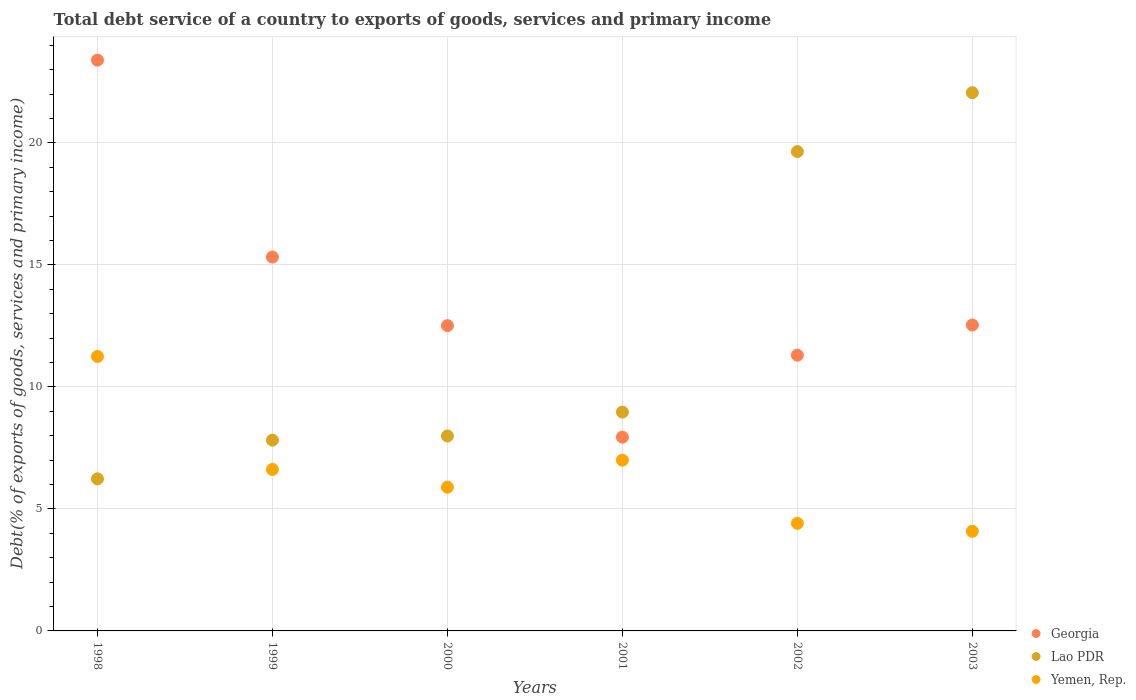How many different coloured dotlines are there?
Provide a succinct answer. 3. Is the number of dotlines equal to the number of legend labels?
Ensure brevity in your answer.  Yes. What is the total debt service in Georgia in 2003?
Ensure brevity in your answer.  12.54. Across all years, what is the maximum total debt service in Yemen, Rep.?
Offer a terse response. 11.25. Across all years, what is the minimum total debt service in Yemen, Rep.?
Your answer should be compact. 4.08. In which year was the total debt service in Lao PDR maximum?
Keep it short and to the point. 2003. In which year was the total debt service in Georgia minimum?
Offer a very short reply. 2001. What is the total total debt service in Georgia in the graph?
Provide a short and direct response. 83.01. What is the difference between the total debt service in Georgia in 1999 and that in 2001?
Offer a very short reply. 7.38. What is the difference between the total debt service in Yemen, Rep. in 2003 and the total debt service in Lao PDR in 2001?
Keep it short and to the point. -4.88. What is the average total debt service in Georgia per year?
Keep it short and to the point. 13.83. In the year 2000, what is the difference between the total debt service in Georgia and total debt service in Lao PDR?
Ensure brevity in your answer.  4.52. In how many years, is the total debt service in Georgia greater than 17 %?
Make the answer very short. 1. What is the ratio of the total debt service in Yemen, Rep. in 2000 to that in 2002?
Offer a terse response. 1.34. What is the difference between the highest and the second highest total debt service in Georgia?
Your answer should be compact. 8.07. What is the difference between the highest and the lowest total debt service in Yemen, Rep.?
Make the answer very short. 7.16. In how many years, is the total debt service in Georgia greater than the average total debt service in Georgia taken over all years?
Provide a succinct answer. 2. Is it the case that in every year, the sum of the total debt service in Georgia and total debt service in Yemen, Rep.  is greater than the total debt service in Lao PDR?
Your answer should be very brief. No. Is the total debt service in Georgia strictly greater than the total debt service in Yemen, Rep. over the years?
Give a very brief answer. Yes. How many years are there in the graph?
Your answer should be compact. 6. What is the difference between two consecutive major ticks on the Y-axis?
Your answer should be compact. 5. Does the graph contain any zero values?
Make the answer very short. No. Does the graph contain grids?
Keep it short and to the point. Yes. How are the legend labels stacked?
Your answer should be very brief. Vertical. What is the title of the graph?
Provide a short and direct response. Total debt service of a country to exports of goods, services and primary income. What is the label or title of the X-axis?
Offer a very short reply. Years. What is the label or title of the Y-axis?
Provide a succinct answer. Debt(% of exports of goods, services and primary income). What is the Debt(% of exports of goods, services and primary income) in Georgia in 1998?
Provide a succinct answer. 23.39. What is the Debt(% of exports of goods, services and primary income) of Lao PDR in 1998?
Offer a terse response. 6.23. What is the Debt(% of exports of goods, services and primary income) in Yemen, Rep. in 1998?
Your response must be concise. 11.25. What is the Debt(% of exports of goods, services and primary income) in Georgia in 1999?
Provide a short and direct response. 15.32. What is the Debt(% of exports of goods, services and primary income) of Lao PDR in 1999?
Make the answer very short. 7.82. What is the Debt(% of exports of goods, services and primary income) in Yemen, Rep. in 1999?
Make the answer very short. 6.62. What is the Debt(% of exports of goods, services and primary income) in Georgia in 2000?
Offer a very short reply. 12.51. What is the Debt(% of exports of goods, services and primary income) in Lao PDR in 2000?
Your response must be concise. 7.99. What is the Debt(% of exports of goods, services and primary income) in Yemen, Rep. in 2000?
Provide a short and direct response. 5.89. What is the Debt(% of exports of goods, services and primary income) of Georgia in 2001?
Provide a succinct answer. 7.94. What is the Debt(% of exports of goods, services and primary income) in Lao PDR in 2001?
Your response must be concise. 8.97. What is the Debt(% of exports of goods, services and primary income) of Yemen, Rep. in 2001?
Provide a succinct answer. 7. What is the Debt(% of exports of goods, services and primary income) in Georgia in 2002?
Your answer should be very brief. 11.3. What is the Debt(% of exports of goods, services and primary income) of Lao PDR in 2002?
Ensure brevity in your answer.  19.65. What is the Debt(% of exports of goods, services and primary income) in Yemen, Rep. in 2002?
Keep it short and to the point. 4.41. What is the Debt(% of exports of goods, services and primary income) of Georgia in 2003?
Your response must be concise. 12.54. What is the Debt(% of exports of goods, services and primary income) in Lao PDR in 2003?
Your answer should be compact. 22.06. What is the Debt(% of exports of goods, services and primary income) in Yemen, Rep. in 2003?
Provide a succinct answer. 4.08. Across all years, what is the maximum Debt(% of exports of goods, services and primary income) of Georgia?
Your response must be concise. 23.39. Across all years, what is the maximum Debt(% of exports of goods, services and primary income) in Lao PDR?
Your response must be concise. 22.06. Across all years, what is the maximum Debt(% of exports of goods, services and primary income) in Yemen, Rep.?
Provide a short and direct response. 11.25. Across all years, what is the minimum Debt(% of exports of goods, services and primary income) of Georgia?
Make the answer very short. 7.94. Across all years, what is the minimum Debt(% of exports of goods, services and primary income) in Lao PDR?
Your answer should be compact. 6.23. Across all years, what is the minimum Debt(% of exports of goods, services and primary income) of Yemen, Rep.?
Your response must be concise. 4.08. What is the total Debt(% of exports of goods, services and primary income) in Georgia in the graph?
Provide a short and direct response. 83.01. What is the total Debt(% of exports of goods, services and primary income) of Lao PDR in the graph?
Your answer should be very brief. 72.71. What is the total Debt(% of exports of goods, services and primary income) of Yemen, Rep. in the graph?
Offer a very short reply. 39.25. What is the difference between the Debt(% of exports of goods, services and primary income) of Georgia in 1998 and that in 1999?
Offer a terse response. 8.07. What is the difference between the Debt(% of exports of goods, services and primary income) in Lao PDR in 1998 and that in 1999?
Offer a very short reply. -1.58. What is the difference between the Debt(% of exports of goods, services and primary income) in Yemen, Rep. in 1998 and that in 1999?
Offer a terse response. 4.63. What is the difference between the Debt(% of exports of goods, services and primary income) of Georgia in 1998 and that in 2000?
Keep it short and to the point. 10.88. What is the difference between the Debt(% of exports of goods, services and primary income) of Lao PDR in 1998 and that in 2000?
Provide a succinct answer. -1.76. What is the difference between the Debt(% of exports of goods, services and primary income) of Yemen, Rep. in 1998 and that in 2000?
Offer a very short reply. 5.36. What is the difference between the Debt(% of exports of goods, services and primary income) of Georgia in 1998 and that in 2001?
Ensure brevity in your answer.  15.45. What is the difference between the Debt(% of exports of goods, services and primary income) in Lao PDR in 1998 and that in 2001?
Offer a very short reply. -2.74. What is the difference between the Debt(% of exports of goods, services and primary income) in Yemen, Rep. in 1998 and that in 2001?
Provide a succinct answer. 4.25. What is the difference between the Debt(% of exports of goods, services and primary income) in Georgia in 1998 and that in 2002?
Make the answer very short. 12.09. What is the difference between the Debt(% of exports of goods, services and primary income) in Lao PDR in 1998 and that in 2002?
Keep it short and to the point. -13.41. What is the difference between the Debt(% of exports of goods, services and primary income) in Yemen, Rep. in 1998 and that in 2002?
Your answer should be compact. 6.84. What is the difference between the Debt(% of exports of goods, services and primary income) in Georgia in 1998 and that in 2003?
Keep it short and to the point. 10.86. What is the difference between the Debt(% of exports of goods, services and primary income) in Lao PDR in 1998 and that in 2003?
Your answer should be very brief. -15.82. What is the difference between the Debt(% of exports of goods, services and primary income) in Yemen, Rep. in 1998 and that in 2003?
Your answer should be very brief. 7.16. What is the difference between the Debt(% of exports of goods, services and primary income) in Georgia in 1999 and that in 2000?
Offer a terse response. 2.81. What is the difference between the Debt(% of exports of goods, services and primary income) in Lao PDR in 1999 and that in 2000?
Your answer should be compact. -0.17. What is the difference between the Debt(% of exports of goods, services and primary income) of Yemen, Rep. in 1999 and that in 2000?
Provide a short and direct response. 0.73. What is the difference between the Debt(% of exports of goods, services and primary income) of Georgia in 1999 and that in 2001?
Make the answer very short. 7.38. What is the difference between the Debt(% of exports of goods, services and primary income) of Lao PDR in 1999 and that in 2001?
Keep it short and to the point. -1.15. What is the difference between the Debt(% of exports of goods, services and primary income) in Yemen, Rep. in 1999 and that in 2001?
Your response must be concise. -0.38. What is the difference between the Debt(% of exports of goods, services and primary income) of Georgia in 1999 and that in 2002?
Your response must be concise. 4.02. What is the difference between the Debt(% of exports of goods, services and primary income) of Lao PDR in 1999 and that in 2002?
Your response must be concise. -11.83. What is the difference between the Debt(% of exports of goods, services and primary income) in Yemen, Rep. in 1999 and that in 2002?
Your answer should be very brief. 2.21. What is the difference between the Debt(% of exports of goods, services and primary income) of Georgia in 1999 and that in 2003?
Offer a terse response. 2.79. What is the difference between the Debt(% of exports of goods, services and primary income) of Lao PDR in 1999 and that in 2003?
Provide a succinct answer. -14.24. What is the difference between the Debt(% of exports of goods, services and primary income) of Yemen, Rep. in 1999 and that in 2003?
Ensure brevity in your answer.  2.54. What is the difference between the Debt(% of exports of goods, services and primary income) in Georgia in 2000 and that in 2001?
Provide a succinct answer. 4.57. What is the difference between the Debt(% of exports of goods, services and primary income) in Lao PDR in 2000 and that in 2001?
Make the answer very short. -0.98. What is the difference between the Debt(% of exports of goods, services and primary income) of Yemen, Rep. in 2000 and that in 2001?
Your response must be concise. -1.11. What is the difference between the Debt(% of exports of goods, services and primary income) in Georgia in 2000 and that in 2002?
Your answer should be very brief. 1.21. What is the difference between the Debt(% of exports of goods, services and primary income) of Lao PDR in 2000 and that in 2002?
Ensure brevity in your answer.  -11.66. What is the difference between the Debt(% of exports of goods, services and primary income) of Yemen, Rep. in 2000 and that in 2002?
Make the answer very short. 1.48. What is the difference between the Debt(% of exports of goods, services and primary income) in Georgia in 2000 and that in 2003?
Ensure brevity in your answer.  -0.02. What is the difference between the Debt(% of exports of goods, services and primary income) of Lao PDR in 2000 and that in 2003?
Provide a succinct answer. -14.07. What is the difference between the Debt(% of exports of goods, services and primary income) in Yemen, Rep. in 2000 and that in 2003?
Offer a terse response. 1.81. What is the difference between the Debt(% of exports of goods, services and primary income) of Georgia in 2001 and that in 2002?
Make the answer very short. -3.36. What is the difference between the Debt(% of exports of goods, services and primary income) of Lao PDR in 2001 and that in 2002?
Make the answer very short. -10.68. What is the difference between the Debt(% of exports of goods, services and primary income) of Yemen, Rep. in 2001 and that in 2002?
Give a very brief answer. 2.59. What is the difference between the Debt(% of exports of goods, services and primary income) of Georgia in 2001 and that in 2003?
Make the answer very short. -4.6. What is the difference between the Debt(% of exports of goods, services and primary income) in Lao PDR in 2001 and that in 2003?
Ensure brevity in your answer.  -13.09. What is the difference between the Debt(% of exports of goods, services and primary income) of Yemen, Rep. in 2001 and that in 2003?
Provide a succinct answer. 2.92. What is the difference between the Debt(% of exports of goods, services and primary income) of Georgia in 2002 and that in 2003?
Your response must be concise. -1.24. What is the difference between the Debt(% of exports of goods, services and primary income) in Lao PDR in 2002 and that in 2003?
Give a very brief answer. -2.41. What is the difference between the Debt(% of exports of goods, services and primary income) in Yemen, Rep. in 2002 and that in 2003?
Your response must be concise. 0.33. What is the difference between the Debt(% of exports of goods, services and primary income) in Georgia in 1998 and the Debt(% of exports of goods, services and primary income) in Lao PDR in 1999?
Your answer should be compact. 15.58. What is the difference between the Debt(% of exports of goods, services and primary income) in Georgia in 1998 and the Debt(% of exports of goods, services and primary income) in Yemen, Rep. in 1999?
Keep it short and to the point. 16.77. What is the difference between the Debt(% of exports of goods, services and primary income) in Lao PDR in 1998 and the Debt(% of exports of goods, services and primary income) in Yemen, Rep. in 1999?
Your answer should be very brief. -0.39. What is the difference between the Debt(% of exports of goods, services and primary income) in Georgia in 1998 and the Debt(% of exports of goods, services and primary income) in Lao PDR in 2000?
Provide a succinct answer. 15.4. What is the difference between the Debt(% of exports of goods, services and primary income) in Georgia in 1998 and the Debt(% of exports of goods, services and primary income) in Yemen, Rep. in 2000?
Give a very brief answer. 17.5. What is the difference between the Debt(% of exports of goods, services and primary income) in Lao PDR in 1998 and the Debt(% of exports of goods, services and primary income) in Yemen, Rep. in 2000?
Your response must be concise. 0.34. What is the difference between the Debt(% of exports of goods, services and primary income) of Georgia in 1998 and the Debt(% of exports of goods, services and primary income) of Lao PDR in 2001?
Provide a short and direct response. 14.42. What is the difference between the Debt(% of exports of goods, services and primary income) in Georgia in 1998 and the Debt(% of exports of goods, services and primary income) in Yemen, Rep. in 2001?
Provide a short and direct response. 16.39. What is the difference between the Debt(% of exports of goods, services and primary income) of Lao PDR in 1998 and the Debt(% of exports of goods, services and primary income) of Yemen, Rep. in 2001?
Provide a succinct answer. -0.77. What is the difference between the Debt(% of exports of goods, services and primary income) in Georgia in 1998 and the Debt(% of exports of goods, services and primary income) in Lao PDR in 2002?
Keep it short and to the point. 3.75. What is the difference between the Debt(% of exports of goods, services and primary income) in Georgia in 1998 and the Debt(% of exports of goods, services and primary income) in Yemen, Rep. in 2002?
Provide a short and direct response. 18.98. What is the difference between the Debt(% of exports of goods, services and primary income) in Lao PDR in 1998 and the Debt(% of exports of goods, services and primary income) in Yemen, Rep. in 2002?
Make the answer very short. 1.82. What is the difference between the Debt(% of exports of goods, services and primary income) in Georgia in 1998 and the Debt(% of exports of goods, services and primary income) in Lao PDR in 2003?
Ensure brevity in your answer.  1.33. What is the difference between the Debt(% of exports of goods, services and primary income) in Georgia in 1998 and the Debt(% of exports of goods, services and primary income) in Yemen, Rep. in 2003?
Your answer should be compact. 19.31. What is the difference between the Debt(% of exports of goods, services and primary income) of Lao PDR in 1998 and the Debt(% of exports of goods, services and primary income) of Yemen, Rep. in 2003?
Offer a terse response. 2.15. What is the difference between the Debt(% of exports of goods, services and primary income) of Georgia in 1999 and the Debt(% of exports of goods, services and primary income) of Lao PDR in 2000?
Make the answer very short. 7.33. What is the difference between the Debt(% of exports of goods, services and primary income) in Georgia in 1999 and the Debt(% of exports of goods, services and primary income) in Yemen, Rep. in 2000?
Your answer should be compact. 9.43. What is the difference between the Debt(% of exports of goods, services and primary income) in Lao PDR in 1999 and the Debt(% of exports of goods, services and primary income) in Yemen, Rep. in 2000?
Ensure brevity in your answer.  1.93. What is the difference between the Debt(% of exports of goods, services and primary income) in Georgia in 1999 and the Debt(% of exports of goods, services and primary income) in Lao PDR in 2001?
Give a very brief answer. 6.35. What is the difference between the Debt(% of exports of goods, services and primary income) in Georgia in 1999 and the Debt(% of exports of goods, services and primary income) in Yemen, Rep. in 2001?
Provide a succinct answer. 8.32. What is the difference between the Debt(% of exports of goods, services and primary income) of Lao PDR in 1999 and the Debt(% of exports of goods, services and primary income) of Yemen, Rep. in 2001?
Ensure brevity in your answer.  0.82. What is the difference between the Debt(% of exports of goods, services and primary income) of Georgia in 1999 and the Debt(% of exports of goods, services and primary income) of Lao PDR in 2002?
Offer a terse response. -4.32. What is the difference between the Debt(% of exports of goods, services and primary income) in Georgia in 1999 and the Debt(% of exports of goods, services and primary income) in Yemen, Rep. in 2002?
Your answer should be very brief. 10.91. What is the difference between the Debt(% of exports of goods, services and primary income) of Lao PDR in 1999 and the Debt(% of exports of goods, services and primary income) of Yemen, Rep. in 2002?
Ensure brevity in your answer.  3.41. What is the difference between the Debt(% of exports of goods, services and primary income) of Georgia in 1999 and the Debt(% of exports of goods, services and primary income) of Lao PDR in 2003?
Your answer should be very brief. -6.74. What is the difference between the Debt(% of exports of goods, services and primary income) of Georgia in 1999 and the Debt(% of exports of goods, services and primary income) of Yemen, Rep. in 2003?
Ensure brevity in your answer.  11.24. What is the difference between the Debt(% of exports of goods, services and primary income) of Lao PDR in 1999 and the Debt(% of exports of goods, services and primary income) of Yemen, Rep. in 2003?
Your response must be concise. 3.73. What is the difference between the Debt(% of exports of goods, services and primary income) of Georgia in 2000 and the Debt(% of exports of goods, services and primary income) of Lao PDR in 2001?
Give a very brief answer. 3.54. What is the difference between the Debt(% of exports of goods, services and primary income) in Georgia in 2000 and the Debt(% of exports of goods, services and primary income) in Yemen, Rep. in 2001?
Your response must be concise. 5.51. What is the difference between the Debt(% of exports of goods, services and primary income) of Lao PDR in 2000 and the Debt(% of exports of goods, services and primary income) of Yemen, Rep. in 2001?
Provide a short and direct response. 0.99. What is the difference between the Debt(% of exports of goods, services and primary income) of Georgia in 2000 and the Debt(% of exports of goods, services and primary income) of Lao PDR in 2002?
Give a very brief answer. -7.13. What is the difference between the Debt(% of exports of goods, services and primary income) in Georgia in 2000 and the Debt(% of exports of goods, services and primary income) in Yemen, Rep. in 2002?
Give a very brief answer. 8.1. What is the difference between the Debt(% of exports of goods, services and primary income) of Lao PDR in 2000 and the Debt(% of exports of goods, services and primary income) of Yemen, Rep. in 2002?
Offer a terse response. 3.58. What is the difference between the Debt(% of exports of goods, services and primary income) of Georgia in 2000 and the Debt(% of exports of goods, services and primary income) of Lao PDR in 2003?
Your answer should be compact. -9.55. What is the difference between the Debt(% of exports of goods, services and primary income) in Georgia in 2000 and the Debt(% of exports of goods, services and primary income) in Yemen, Rep. in 2003?
Your response must be concise. 8.43. What is the difference between the Debt(% of exports of goods, services and primary income) in Lao PDR in 2000 and the Debt(% of exports of goods, services and primary income) in Yemen, Rep. in 2003?
Provide a succinct answer. 3.91. What is the difference between the Debt(% of exports of goods, services and primary income) of Georgia in 2001 and the Debt(% of exports of goods, services and primary income) of Lao PDR in 2002?
Provide a short and direct response. -11.7. What is the difference between the Debt(% of exports of goods, services and primary income) of Georgia in 2001 and the Debt(% of exports of goods, services and primary income) of Yemen, Rep. in 2002?
Provide a short and direct response. 3.53. What is the difference between the Debt(% of exports of goods, services and primary income) in Lao PDR in 2001 and the Debt(% of exports of goods, services and primary income) in Yemen, Rep. in 2002?
Provide a short and direct response. 4.56. What is the difference between the Debt(% of exports of goods, services and primary income) in Georgia in 2001 and the Debt(% of exports of goods, services and primary income) in Lao PDR in 2003?
Give a very brief answer. -14.12. What is the difference between the Debt(% of exports of goods, services and primary income) of Georgia in 2001 and the Debt(% of exports of goods, services and primary income) of Yemen, Rep. in 2003?
Keep it short and to the point. 3.86. What is the difference between the Debt(% of exports of goods, services and primary income) in Lao PDR in 2001 and the Debt(% of exports of goods, services and primary income) in Yemen, Rep. in 2003?
Give a very brief answer. 4.88. What is the difference between the Debt(% of exports of goods, services and primary income) of Georgia in 2002 and the Debt(% of exports of goods, services and primary income) of Lao PDR in 2003?
Offer a terse response. -10.76. What is the difference between the Debt(% of exports of goods, services and primary income) in Georgia in 2002 and the Debt(% of exports of goods, services and primary income) in Yemen, Rep. in 2003?
Provide a succinct answer. 7.22. What is the difference between the Debt(% of exports of goods, services and primary income) of Lao PDR in 2002 and the Debt(% of exports of goods, services and primary income) of Yemen, Rep. in 2003?
Offer a terse response. 15.56. What is the average Debt(% of exports of goods, services and primary income) of Georgia per year?
Provide a short and direct response. 13.83. What is the average Debt(% of exports of goods, services and primary income) in Lao PDR per year?
Your response must be concise. 12.12. What is the average Debt(% of exports of goods, services and primary income) of Yemen, Rep. per year?
Give a very brief answer. 6.54. In the year 1998, what is the difference between the Debt(% of exports of goods, services and primary income) of Georgia and Debt(% of exports of goods, services and primary income) of Lao PDR?
Give a very brief answer. 17.16. In the year 1998, what is the difference between the Debt(% of exports of goods, services and primary income) in Georgia and Debt(% of exports of goods, services and primary income) in Yemen, Rep.?
Provide a short and direct response. 12.14. In the year 1998, what is the difference between the Debt(% of exports of goods, services and primary income) in Lao PDR and Debt(% of exports of goods, services and primary income) in Yemen, Rep.?
Provide a succinct answer. -5.02. In the year 1999, what is the difference between the Debt(% of exports of goods, services and primary income) of Georgia and Debt(% of exports of goods, services and primary income) of Lao PDR?
Your answer should be compact. 7.51. In the year 1999, what is the difference between the Debt(% of exports of goods, services and primary income) in Georgia and Debt(% of exports of goods, services and primary income) in Yemen, Rep.?
Your answer should be very brief. 8.7. In the year 1999, what is the difference between the Debt(% of exports of goods, services and primary income) in Lao PDR and Debt(% of exports of goods, services and primary income) in Yemen, Rep.?
Your answer should be compact. 1.2. In the year 2000, what is the difference between the Debt(% of exports of goods, services and primary income) in Georgia and Debt(% of exports of goods, services and primary income) in Lao PDR?
Ensure brevity in your answer.  4.52. In the year 2000, what is the difference between the Debt(% of exports of goods, services and primary income) of Georgia and Debt(% of exports of goods, services and primary income) of Yemen, Rep.?
Your answer should be compact. 6.62. In the year 2000, what is the difference between the Debt(% of exports of goods, services and primary income) in Lao PDR and Debt(% of exports of goods, services and primary income) in Yemen, Rep.?
Offer a terse response. 2.1. In the year 2001, what is the difference between the Debt(% of exports of goods, services and primary income) in Georgia and Debt(% of exports of goods, services and primary income) in Lao PDR?
Give a very brief answer. -1.03. In the year 2001, what is the difference between the Debt(% of exports of goods, services and primary income) of Georgia and Debt(% of exports of goods, services and primary income) of Yemen, Rep.?
Your response must be concise. 0.94. In the year 2001, what is the difference between the Debt(% of exports of goods, services and primary income) of Lao PDR and Debt(% of exports of goods, services and primary income) of Yemen, Rep.?
Provide a succinct answer. 1.97. In the year 2002, what is the difference between the Debt(% of exports of goods, services and primary income) of Georgia and Debt(% of exports of goods, services and primary income) of Lao PDR?
Give a very brief answer. -8.34. In the year 2002, what is the difference between the Debt(% of exports of goods, services and primary income) of Georgia and Debt(% of exports of goods, services and primary income) of Yemen, Rep.?
Give a very brief answer. 6.89. In the year 2002, what is the difference between the Debt(% of exports of goods, services and primary income) of Lao PDR and Debt(% of exports of goods, services and primary income) of Yemen, Rep.?
Offer a terse response. 15.24. In the year 2003, what is the difference between the Debt(% of exports of goods, services and primary income) of Georgia and Debt(% of exports of goods, services and primary income) of Lao PDR?
Your response must be concise. -9.52. In the year 2003, what is the difference between the Debt(% of exports of goods, services and primary income) of Georgia and Debt(% of exports of goods, services and primary income) of Yemen, Rep.?
Ensure brevity in your answer.  8.45. In the year 2003, what is the difference between the Debt(% of exports of goods, services and primary income) in Lao PDR and Debt(% of exports of goods, services and primary income) in Yemen, Rep.?
Your answer should be compact. 17.97. What is the ratio of the Debt(% of exports of goods, services and primary income) in Georgia in 1998 to that in 1999?
Give a very brief answer. 1.53. What is the ratio of the Debt(% of exports of goods, services and primary income) in Lao PDR in 1998 to that in 1999?
Provide a short and direct response. 0.8. What is the ratio of the Debt(% of exports of goods, services and primary income) in Yemen, Rep. in 1998 to that in 1999?
Your answer should be very brief. 1.7. What is the ratio of the Debt(% of exports of goods, services and primary income) of Georgia in 1998 to that in 2000?
Your answer should be very brief. 1.87. What is the ratio of the Debt(% of exports of goods, services and primary income) in Lao PDR in 1998 to that in 2000?
Keep it short and to the point. 0.78. What is the ratio of the Debt(% of exports of goods, services and primary income) in Yemen, Rep. in 1998 to that in 2000?
Your response must be concise. 1.91. What is the ratio of the Debt(% of exports of goods, services and primary income) of Georgia in 1998 to that in 2001?
Your answer should be very brief. 2.95. What is the ratio of the Debt(% of exports of goods, services and primary income) of Lao PDR in 1998 to that in 2001?
Give a very brief answer. 0.69. What is the ratio of the Debt(% of exports of goods, services and primary income) in Yemen, Rep. in 1998 to that in 2001?
Offer a very short reply. 1.61. What is the ratio of the Debt(% of exports of goods, services and primary income) of Georgia in 1998 to that in 2002?
Your answer should be very brief. 2.07. What is the ratio of the Debt(% of exports of goods, services and primary income) in Lao PDR in 1998 to that in 2002?
Your answer should be compact. 0.32. What is the ratio of the Debt(% of exports of goods, services and primary income) in Yemen, Rep. in 1998 to that in 2002?
Make the answer very short. 2.55. What is the ratio of the Debt(% of exports of goods, services and primary income) in Georgia in 1998 to that in 2003?
Ensure brevity in your answer.  1.87. What is the ratio of the Debt(% of exports of goods, services and primary income) in Lao PDR in 1998 to that in 2003?
Your answer should be very brief. 0.28. What is the ratio of the Debt(% of exports of goods, services and primary income) of Yemen, Rep. in 1998 to that in 2003?
Offer a terse response. 2.75. What is the ratio of the Debt(% of exports of goods, services and primary income) of Georgia in 1999 to that in 2000?
Provide a succinct answer. 1.22. What is the ratio of the Debt(% of exports of goods, services and primary income) of Lao PDR in 1999 to that in 2000?
Give a very brief answer. 0.98. What is the ratio of the Debt(% of exports of goods, services and primary income) in Yemen, Rep. in 1999 to that in 2000?
Your response must be concise. 1.12. What is the ratio of the Debt(% of exports of goods, services and primary income) of Georgia in 1999 to that in 2001?
Keep it short and to the point. 1.93. What is the ratio of the Debt(% of exports of goods, services and primary income) in Lao PDR in 1999 to that in 2001?
Make the answer very short. 0.87. What is the ratio of the Debt(% of exports of goods, services and primary income) of Yemen, Rep. in 1999 to that in 2001?
Offer a very short reply. 0.95. What is the ratio of the Debt(% of exports of goods, services and primary income) of Georgia in 1999 to that in 2002?
Your answer should be very brief. 1.36. What is the ratio of the Debt(% of exports of goods, services and primary income) in Lao PDR in 1999 to that in 2002?
Your response must be concise. 0.4. What is the ratio of the Debt(% of exports of goods, services and primary income) of Yemen, Rep. in 1999 to that in 2002?
Ensure brevity in your answer.  1.5. What is the ratio of the Debt(% of exports of goods, services and primary income) of Georgia in 1999 to that in 2003?
Make the answer very short. 1.22. What is the ratio of the Debt(% of exports of goods, services and primary income) of Lao PDR in 1999 to that in 2003?
Your response must be concise. 0.35. What is the ratio of the Debt(% of exports of goods, services and primary income) in Yemen, Rep. in 1999 to that in 2003?
Provide a succinct answer. 1.62. What is the ratio of the Debt(% of exports of goods, services and primary income) in Georgia in 2000 to that in 2001?
Ensure brevity in your answer.  1.58. What is the ratio of the Debt(% of exports of goods, services and primary income) in Lao PDR in 2000 to that in 2001?
Your answer should be very brief. 0.89. What is the ratio of the Debt(% of exports of goods, services and primary income) in Yemen, Rep. in 2000 to that in 2001?
Offer a terse response. 0.84. What is the ratio of the Debt(% of exports of goods, services and primary income) of Georgia in 2000 to that in 2002?
Provide a short and direct response. 1.11. What is the ratio of the Debt(% of exports of goods, services and primary income) in Lao PDR in 2000 to that in 2002?
Offer a very short reply. 0.41. What is the ratio of the Debt(% of exports of goods, services and primary income) of Yemen, Rep. in 2000 to that in 2002?
Keep it short and to the point. 1.34. What is the ratio of the Debt(% of exports of goods, services and primary income) of Lao PDR in 2000 to that in 2003?
Your answer should be very brief. 0.36. What is the ratio of the Debt(% of exports of goods, services and primary income) of Yemen, Rep. in 2000 to that in 2003?
Your response must be concise. 1.44. What is the ratio of the Debt(% of exports of goods, services and primary income) in Georgia in 2001 to that in 2002?
Offer a very short reply. 0.7. What is the ratio of the Debt(% of exports of goods, services and primary income) of Lao PDR in 2001 to that in 2002?
Provide a succinct answer. 0.46. What is the ratio of the Debt(% of exports of goods, services and primary income) of Yemen, Rep. in 2001 to that in 2002?
Keep it short and to the point. 1.59. What is the ratio of the Debt(% of exports of goods, services and primary income) of Georgia in 2001 to that in 2003?
Offer a very short reply. 0.63. What is the ratio of the Debt(% of exports of goods, services and primary income) in Lao PDR in 2001 to that in 2003?
Keep it short and to the point. 0.41. What is the ratio of the Debt(% of exports of goods, services and primary income) in Yemen, Rep. in 2001 to that in 2003?
Ensure brevity in your answer.  1.71. What is the ratio of the Debt(% of exports of goods, services and primary income) in Georgia in 2002 to that in 2003?
Your answer should be very brief. 0.9. What is the ratio of the Debt(% of exports of goods, services and primary income) in Lao PDR in 2002 to that in 2003?
Make the answer very short. 0.89. What is the difference between the highest and the second highest Debt(% of exports of goods, services and primary income) of Georgia?
Give a very brief answer. 8.07. What is the difference between the highest and the second highest Debt(% of exports of goods, services and primary income) of Lao PDR?
Make the answer very short. 2.41. What is the difference between the highest and the second highest Debt(% of exports of goods, services and primary income) in Yemen, Rep.?
Offer a terse response. 4.25. What is the difference between the highest and the lowest Debt(% of exports of goods, services and primary income) in Georgia?
Keep it short and to the point. 15.45. What is the difference between the highest and the lowest Debt(% of exports of goods, services and primary income) of Lao PDR?
Make the answer very short. 15.82. What is the difference between the highest and the lowest Debt(% of exports of goods, services and primary income) of Yemen, Rep.?
Keep it short and to the point. 7.16. 